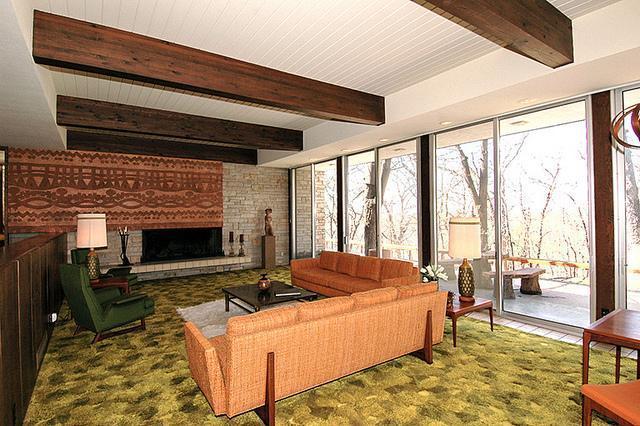How many couches are visible?
Give a very brief answer. 2. How many chairs are there?
Give a very brief answer. 2. 